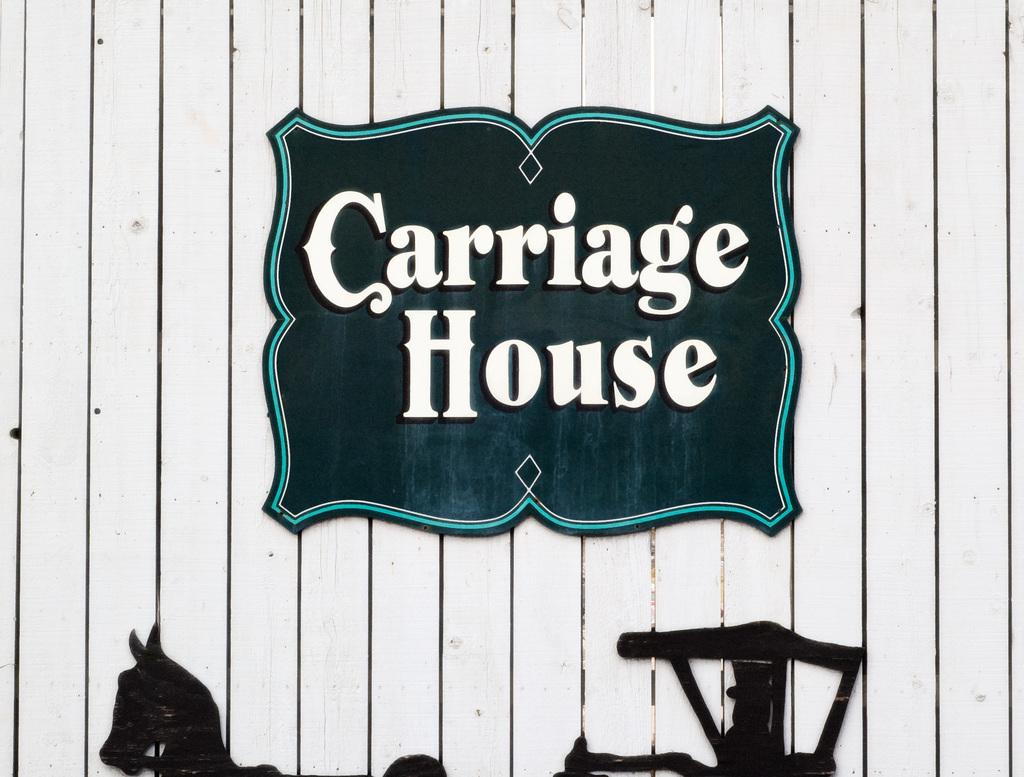What type of wall is visible in the image? There is a wooden wall in the image. What is attached to the wooden wall? There is a board with text written on it in the image. What else can be seen on the wooden wall? There is a horse cart frame on the wall in the image. What type of engine is powering the scene in the image? There is no engine present in the image, and the scene does not involve any powered movement. 